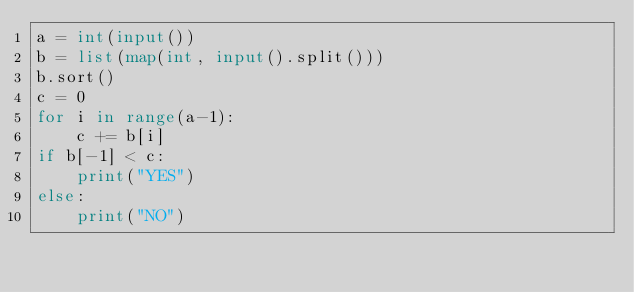<code> <loc_0><loc_0><loc_500><loc_500><_Python_>a = int(input())
b = list(map(int, input().split()))
b.sort()
c = 0
for i in range(a-1):
    c += b[i]
if b[-1] < c:
    print("YES")
else:
    print("NO")
</code> 